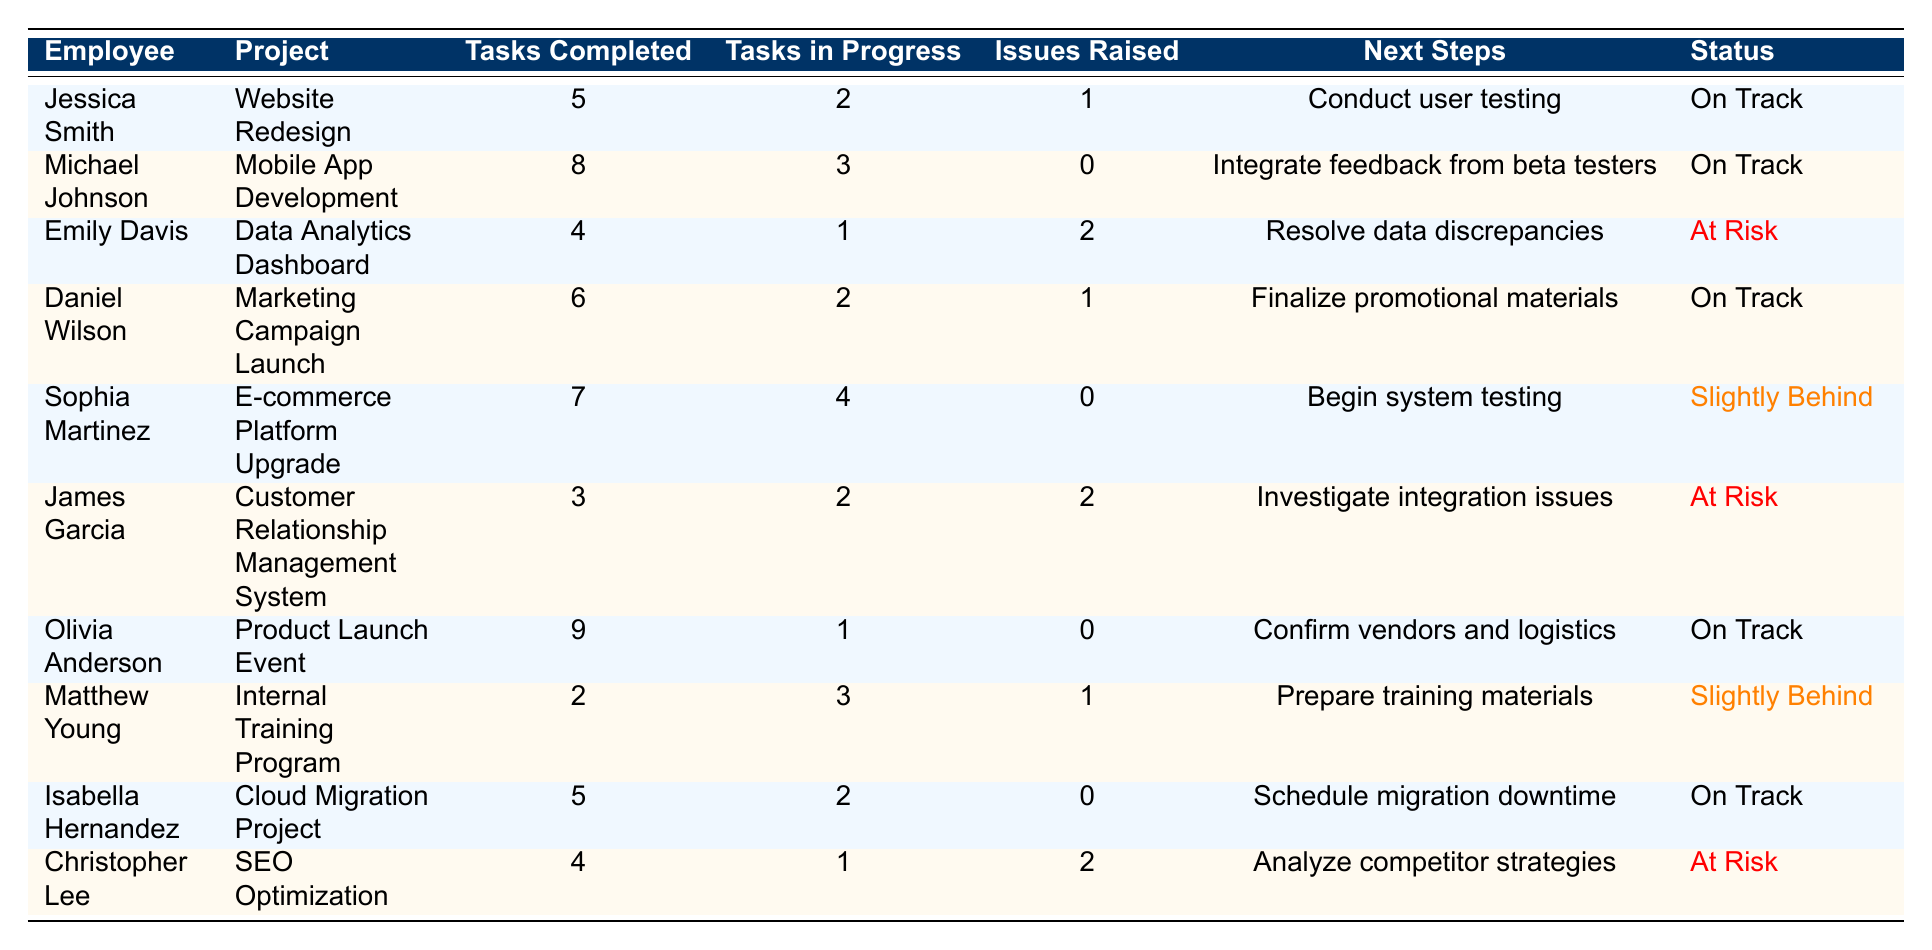What is the total number of tasks completed across all projects? To find the total tasks completed, sum up the "Tasks Completed" column: 5 + 8 + 4 + 6 + 7 + 3 + 9 + 2 + 5 + 4 = 59.
Answer: 59 Which employee has the highest number of tasks completed? Looking at the "Tasks Completed" column, Olivia Anderson has 9 tasks completed, the highest among all employees.
Answer: Olivia Anderson How many employees have their project status marked as "At Risk"? By counting the rows with "At Risk" in the "Status" column, there are 3 employees: Emily Davis, James Garcia, and Christopher Lee.
Answer: 3 What are the next steps for Sophia Martinez? Referring to the "Next Steps" column for Sophia Martinez, the answer is "Begin system testing."
Answer: Begin system testing Is there any project with zero issues raised? Checking the "Issues Raised" column, the projects by Michael Johnson, Olivia Anderson, and Isabella Hernandez show zero issues raised. Therefore, yes, there are projects with zero issues.
Answer: Yes What is the average number of tasks in progress for all employees? To find the average, sum the "Tasks in Progress" values (2 + 3 + 1 + 2 + 4 + 2 + 1 + 3 + 2 + 1 = 20) and divide by 10 (the number of employees). So, the average is 20 / 10 = 2.
Answer: 2 Which two employees are slightly behind schedule? Checking the "Status" column, the employees with "Slightly Behind" status are Sophia Martinez and Matthew Young.
Answer: Sophia Martinez and Matthew Young What is the total number of issues raised by employees working on projects that are at risk? Identify employees with "At Risk" status: Emily Davis (2 issues), James Garcia (2 issues), and Christopher Lee (2 issues). Adding them gives 2 + 2 + 2 = 6.
Answer: 6 What project is Jessica Smith working on, and what is her status? Referring to the table, Jessica Smith is working on the "Website Redesign" project, and her status is "On Track."
Answer: Website Redesign, On Track How many tasks in progress does Daniel Wilson have? Looking at Daniel Wilson's row, he has 2 tasks in progress as per the "Tasks in Progress" column.
Answer: 2 Which project requires "Investigate integration issues" next? The "Next Steps" column shows that James Garcia's project requires "Investigate integration issues."
Answer: Customer Relationship Management System 